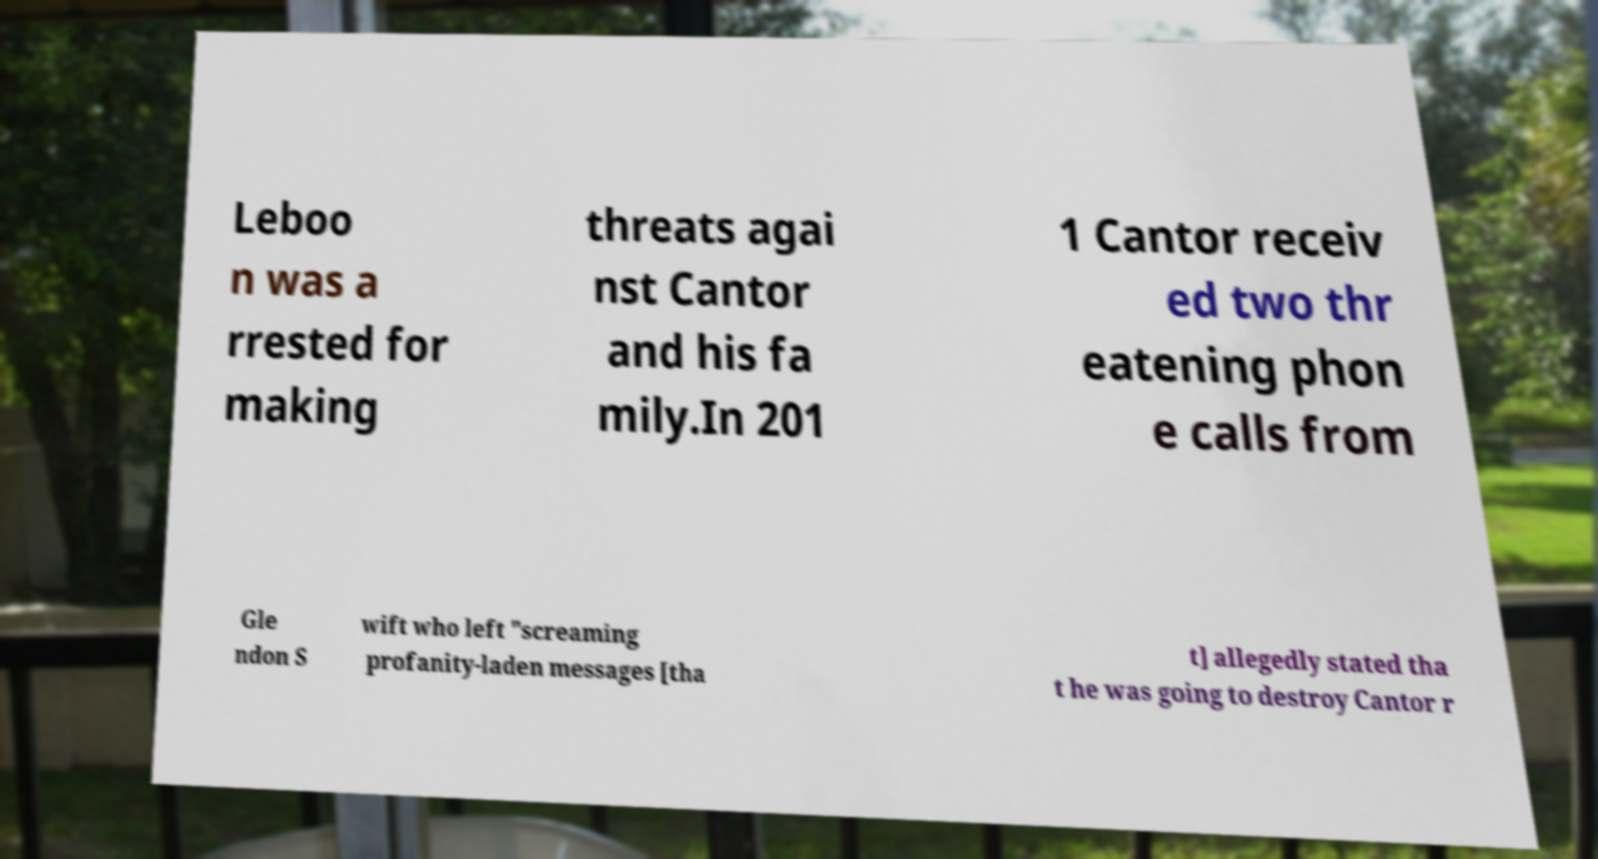Can you read and provide the text displayed in the image?This photo seems to have some interesting text. Can you extract and type it out for me? Leboo n was a rrested for making threats agai nst Cantor and his fa mily.In 201 1 Cantor receiv ed two thr eatening phon e calls from Gle ndon S wift who left "screaming profanity-laden messages [tha t] allegedly stated tha t he was going to destroy Cantor r 